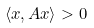Convert formula to latex. <formula><loc_0><loc_0><loc_500><loc_500>\langle x , A x \rangle > 0</formula> 